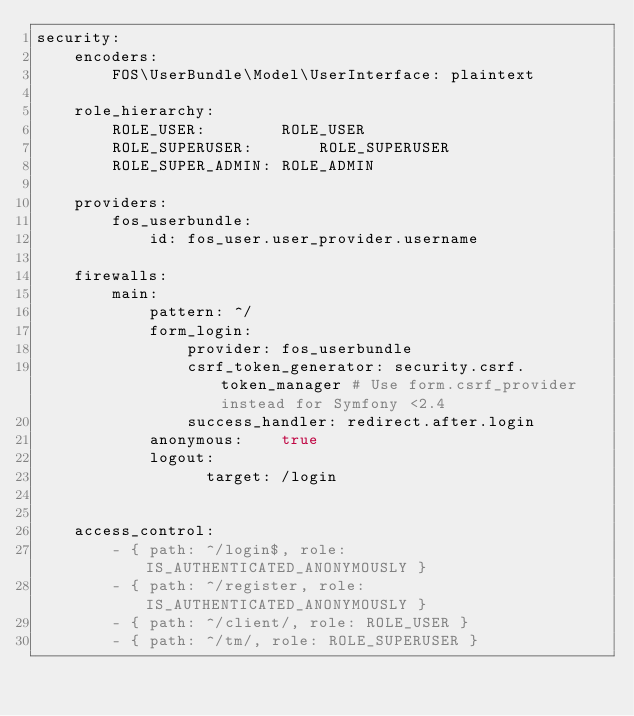<code> <loc_0><loc_0><loc_500><loc_500><_YAML_>security:
    encoders:
        FOS\UserBundle\Model\UserInterface: plaintext

    role_hierarchy:
        ROLE_USER:        ROLE_USER
        ROLE_SUPERUSER:       ROLE_SUPERUSER
        ROLE_SUPER_ADMIN: ROLE_ADMIN

    providers:
        fos_userbundle:
            id: fos_user.user_provider.username

    firewalls:
        main:
            pattern: ^/
            form_login:
                provider: fos_userbundle
                csrf_token_generator: security.csrf.token_manager # Use form.csrf_provider instead for Symfony <2.4
                success_handler: redirect.after.login
            anonymous:    true
            logout:
                  target: /login


    access_control:
        - { path: ^/login$, role: IS_AUTHENTICATED_ANONYMOUSLY }
        - { path: ^/register, role: IS_AUTHENTICATED_ANONYMOUSLY }
        - { path: ^/client/, role: ROLE_USER }
        - { path: ^/tm/, role: ROLE_SUPERUSER }</code> 